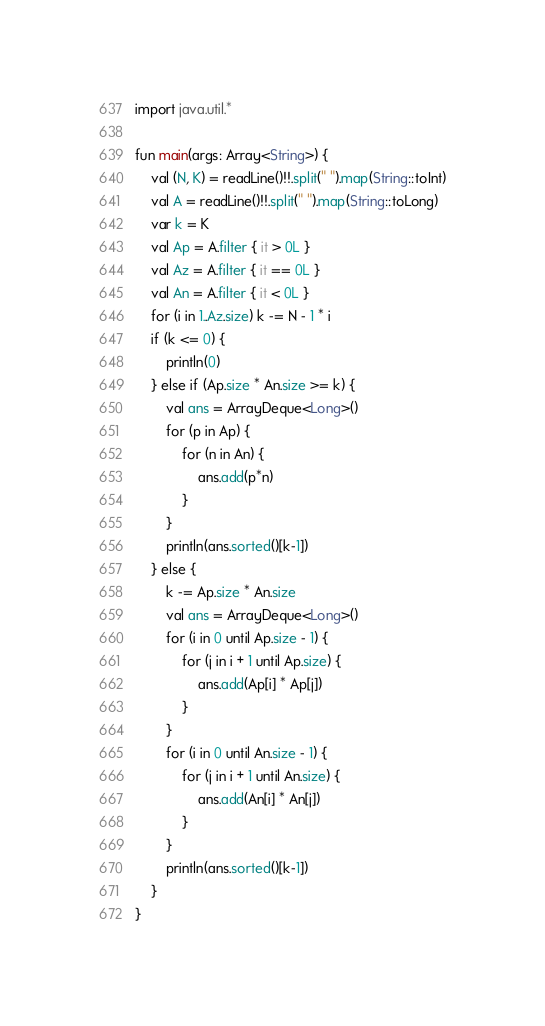Convert code to text. <code><loc_0><loc_0><loc_500><loc_500><_Kotlin_>import java.util.*

fun main(args: Array<String>) {
    val (N, K) = readLine()!!.split(" ").map(String::toInt)
    val A = readLine()!!.split(" ").map(String::toLong)
    var k = K
    val Ap = A.filter { it > 0L }
    val Az = A.filter { it == 0L }
    val An = A.filter { it < 0L }
    for (i in 1..Az.size) k -= N - 1 * i
    if (k <= 0) {
        println(0)
    } else if (Ap.size * An.size >= k) {
        val ans = ArrayDeque<Long>()
        for (p in Ap) {
            for (n in An) {
                ans.add(p*n)
            }
        }
        println(ans.sorted()[k-1])
    } else {
        k -= Ap.size * An.size
        val ans = ArrayDeque<Long>()
        for (i in 0 until Ap.size - 1) {
            for (j in i + 1 until Ap.size) {
                ans.add(Ap[i] * Ap[j])
            }
        }
        for (i in 0 until An.size - 1) {
            for (j in i + 1 until An.size) {
                ans.add(An[i] * An[j])
            }
        }
        println(ans.sorted()[k-1])
    }
}</code> 